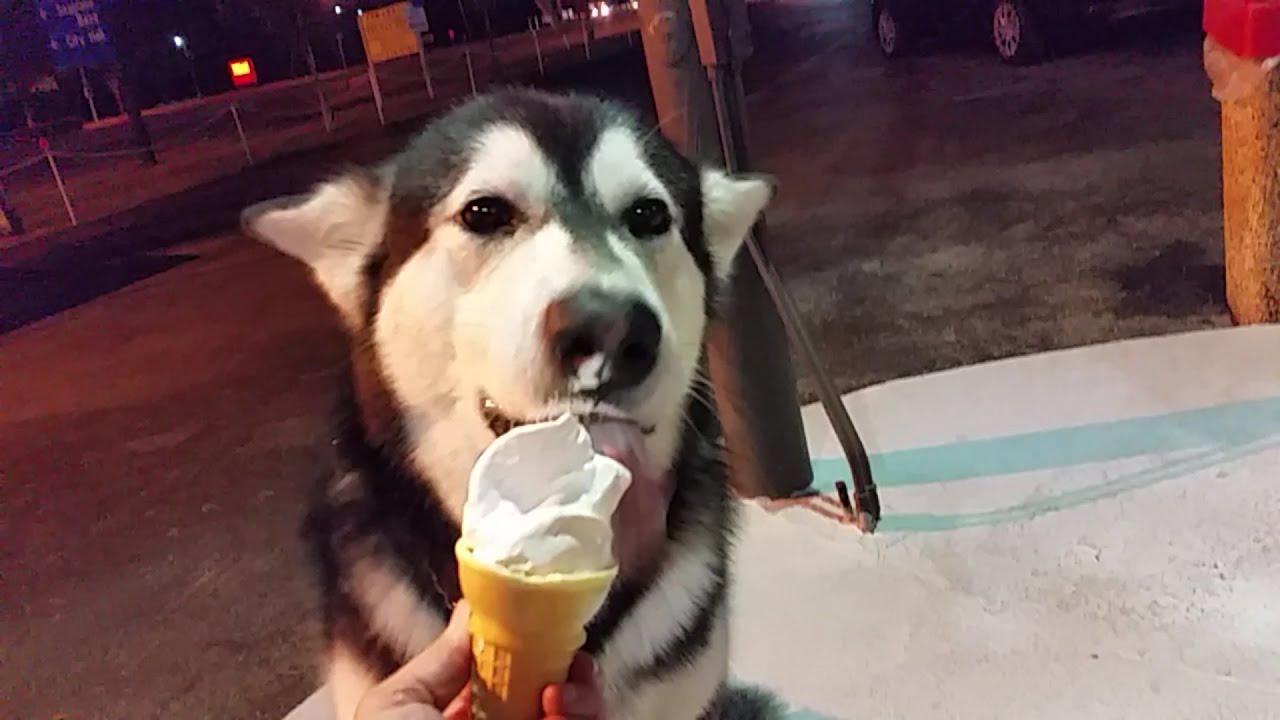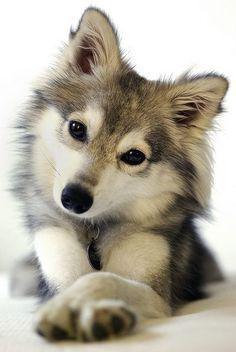The first image is the image on the left, the second image is the image on the right. Given the left and right images, does the statement "One of the treats is on a popsicle stick." hold true? Answer yes or no. No. The first image is the image on the left, the second image is the image on the right. Examine the images to the left and right. Is the description "The left image shows  a hand offering white ice cream to a forward-facing husky dog." accurate? Answer yes or no. Yes. 